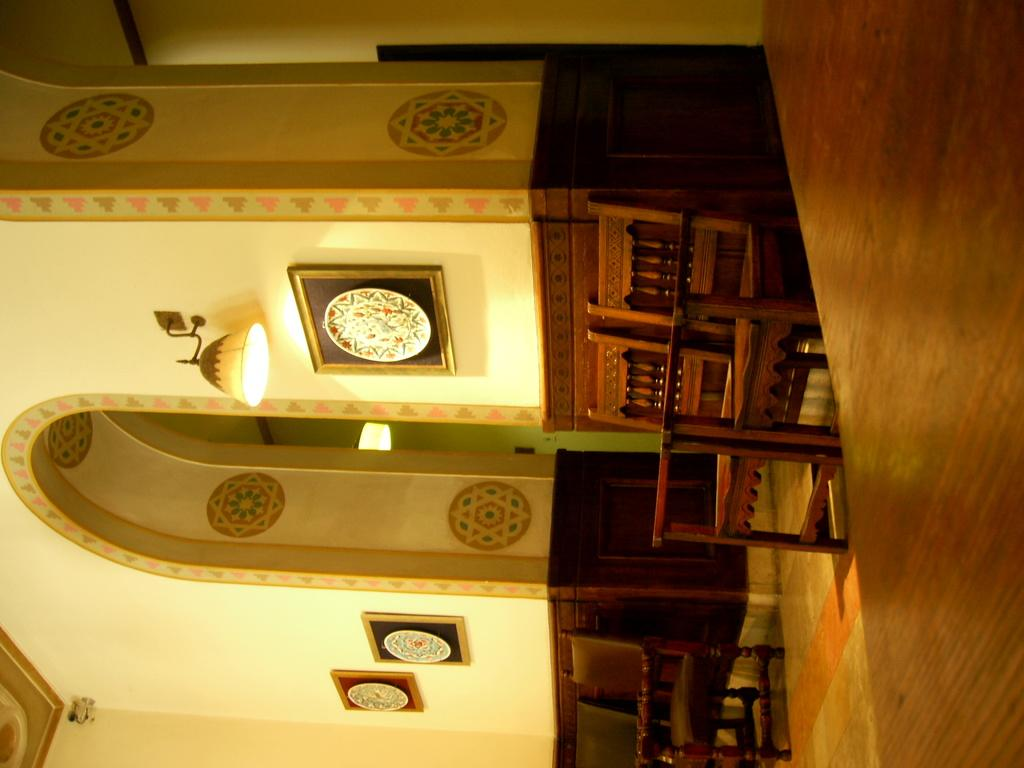Where is the image taken? The image is inside a building. What can be seen on the right side of the image? There are chairs on the right side of the image. What architectural feature is present in the image? There are arches in the image. What is on the wall in the image? There are images and a light on the wall, as well as photo frames. What type of oatmeal is being served in the image? There is no oatmeal present in the image. What is the cause of the loss experienced by the people in the image? There is no indication of loss or any people in the image. 